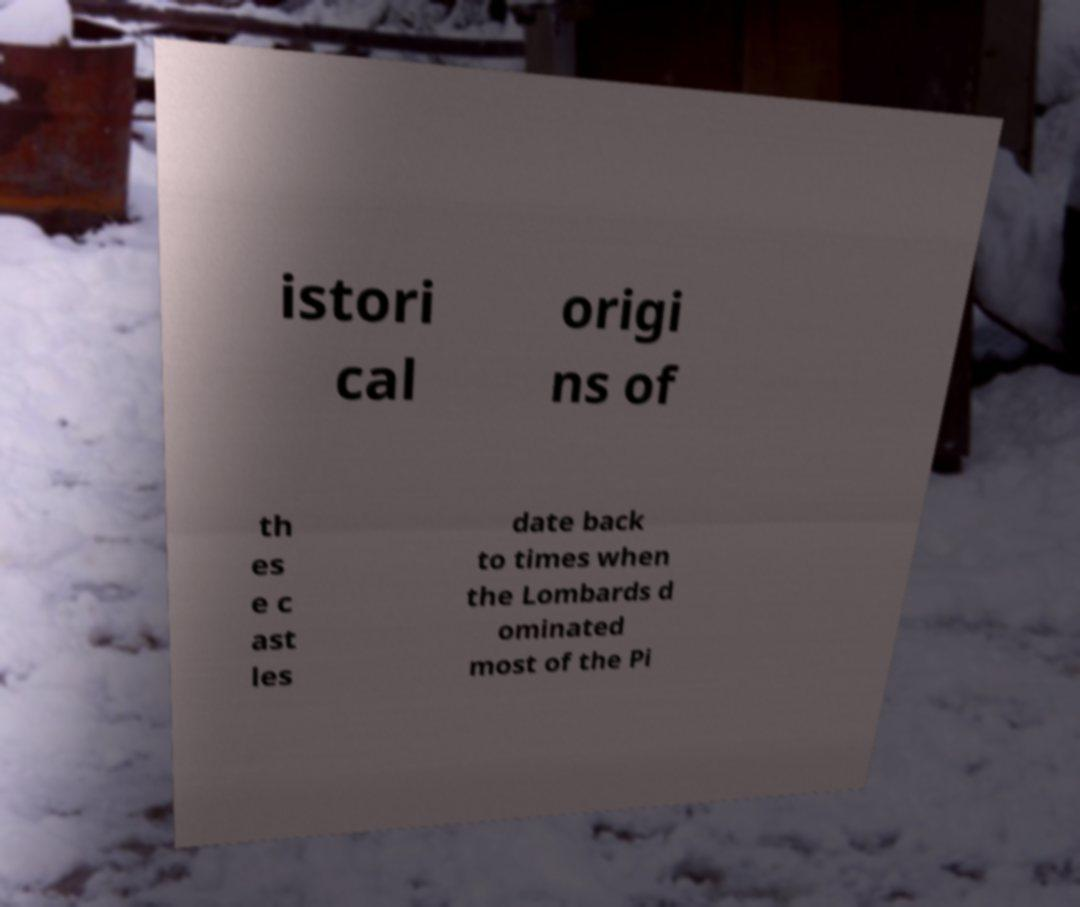For documentation purposes, I need the text within this image transcribed. Could you provide that? istori cal origi ns of th es e c ast les date back to times when the Lombards d ominated most of the Pi 